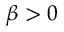Convert formula to latex. <formula><loc_0><loc_0><loc_500><loc_500>\beta > 0</formula> 